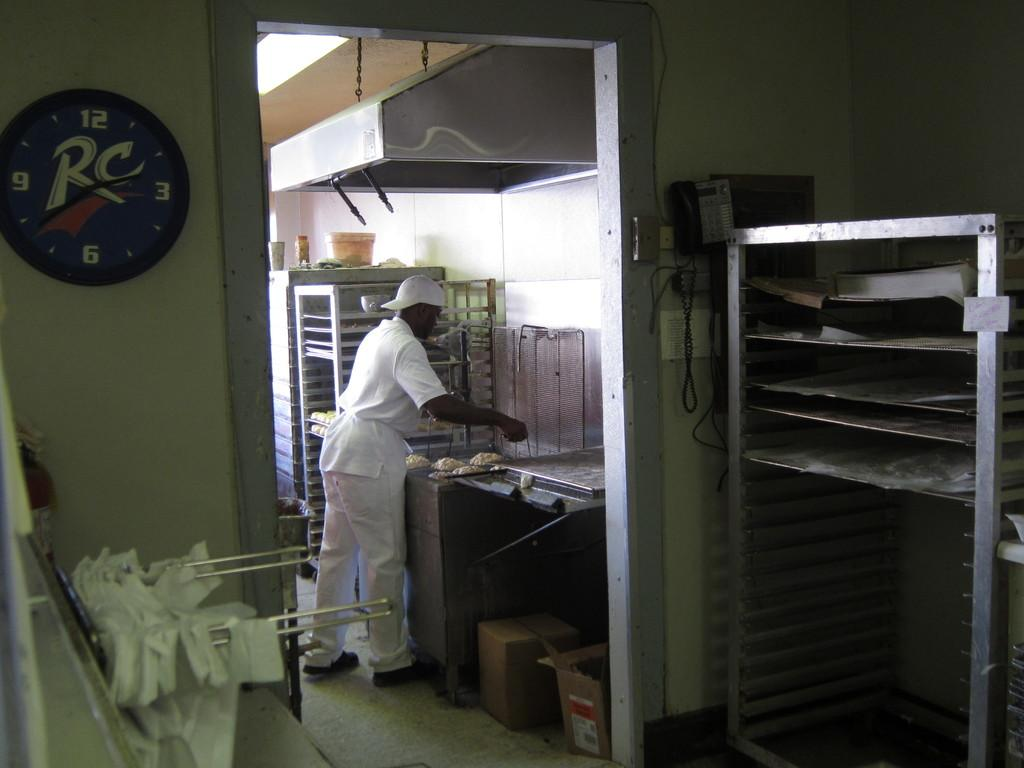<image>
Offer a succinct explanation of the picture presented. A clock with an RC logo is hanging on the wall. 